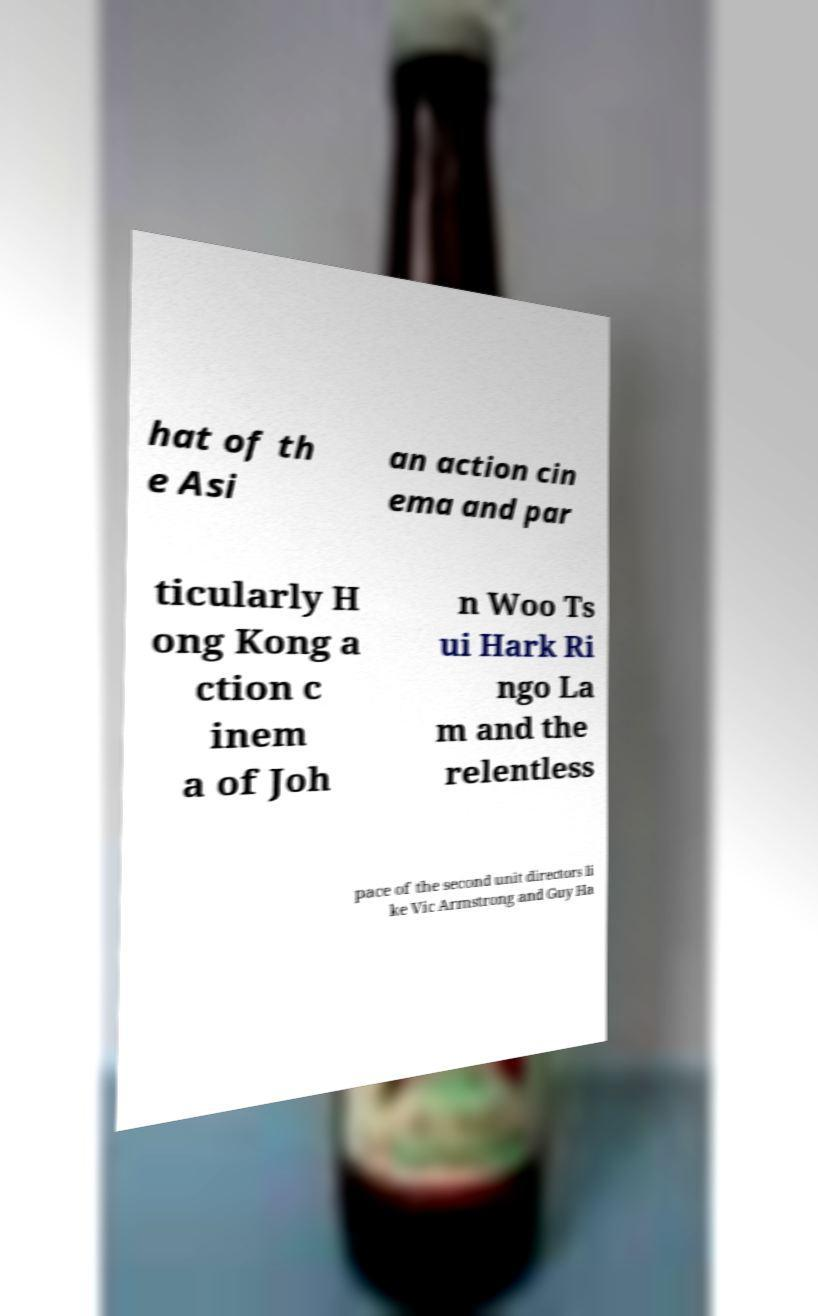There's text embedded in this image that I need extracted. Can you transcribe it verbatim? hat of th e Asi an action cin ema and par ticularly H ong Kong a ction c inem a of Joh n Woo Ts ui Hark Ri ngo La m and the relentless pace of the second unit directors li ke Vic Armstrong and Guy Ha 